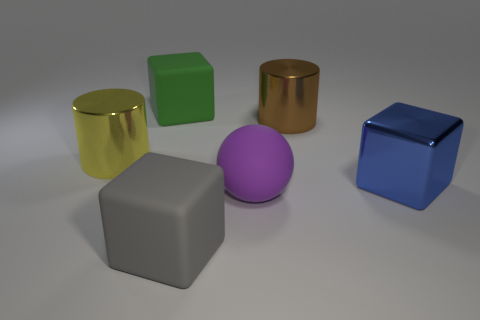What is the blue object made of?
Ensure brevity in your answer.  Metal. Are the big cylinder that is on the left side of the large green thing and the gray object made of the same material?
Provide a succinct answer. No. Are there fewer yellow things that are in front of the purple thing than large purple matte balls?
Offer a very short reply. Yes. There is another metallic block that is the same size as the gray block; what color is it?
Your answer should be compact. Blue. What number of big brown things are the same shape as the purple thing?
Provide a succinct answer. 0. The thing that is right of the brown metallic cylinder is what color?
Provide a succinct answer. Blue. What number of matte objects are big blue balls or big green blocks?
Give a very brief answer. 1. What number of purple things are the same size as the purple matte ball?
Your response must be concise. 0. There is a big block that is in front of the yellow object and behind the large purple ball; what is its color?
Give a very brief answer. Blue. What number of objects are large blue metal blocks or big brown metal things?
Offer a very short reply. 2. 